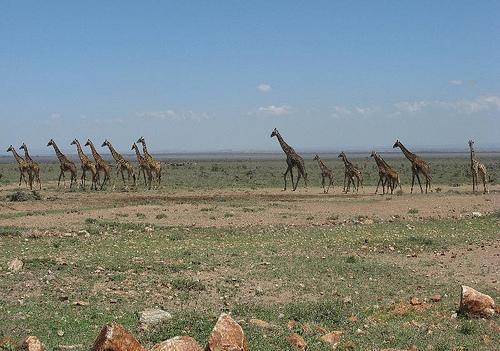How many giraffes are in this pic?
Give a very brief answer. 15. How many fingers does the man have?
Give a very brief answer. 0. 